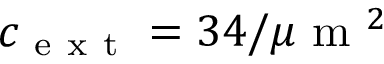<formula> <loc_0><loc_0><loc_500><loc_500>c _ { e x t } = 3 4 / \mu m ^ { 2 }</formula> 